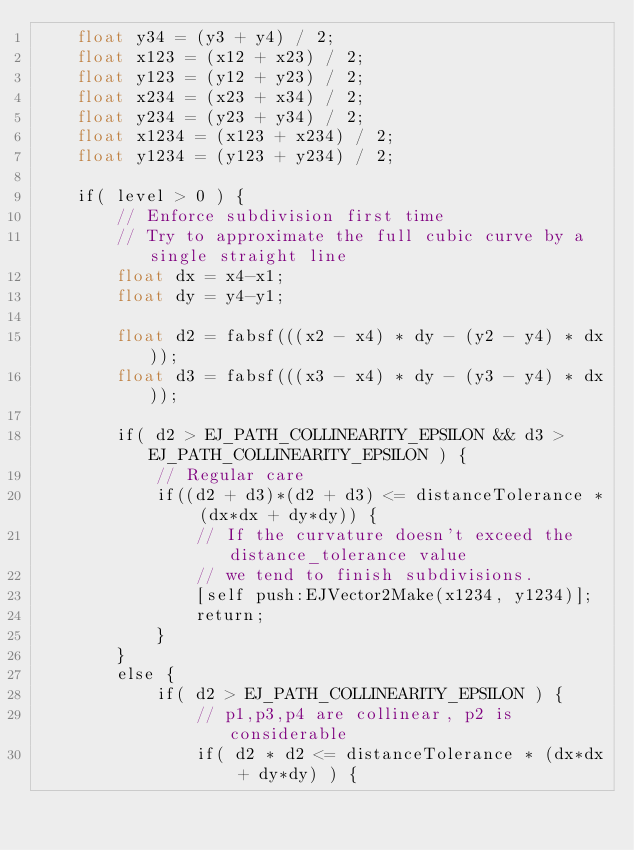Convert code to text. <code><loc_0><loc_0><loc_500><loc_500><_ObjectiveC_>	float y34 = (y3 + y4) / 2;
	float x123 = (x12 + x23) / 2;
	float y123 = (y12 + y23) / 2;
	float x234 = (x23 + x34) / 2;
	float y234 = (y23 + y34) / 2;
	float x1234 = (x123 + x234) / 2;
	float y1234 = (y123 + y234) / 2;
	
	if( level > 0 ) {
		// Enforce subdivision first time
		// Try to approximate the full cubic curve by a single straight line
		float dx = x4-x1;
		float dy = y4-y1;
		
		float d2 = fabsf(((x2 - x4) * dy - (y2 - y4) * dx));
		float d3 = fabsf(((x3 - x4) * dy - (y3 - y4) * dx));
		
		if( d2 > EJ_PATH_COLLINEARITY_EPSILON && d3 > EJ_PATH_COLLINEARITY_EPSILON ) {
			// Regular care
			if((d2 + d3)*(d2 + d3) <= distanceTolerance * (dx*dx + dy*dy)) {
				// If the curvature doesn't exceed the distance_tolerance value
				// we tend to finish subdivisions.
				[self push:EJVector2Make(x1234, y1234)];
				return;
			}
		}
		else {
			if( d2 > EJ_PATH_COLLINEARITY_EPSILON ) {
				// p1,p3,p4 are collinear, p2 is considerable
				if( d2 * d2 <= distanceTolerance * (dx*dx + dy*dy) ) {</code> 